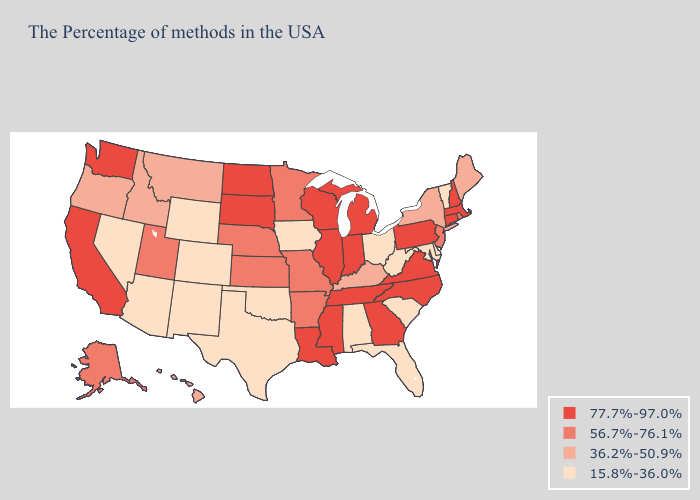Name the states that have a value in the range 36.2%-50.9%?
Keep it brief. Maine, New York, Kentucky, Montana, Idaho, Oregon, Hawaii. What is the lowest value in the Northeast?
Keep it brief. 15.8%-36.0%. Among the states that border Idaho , which have the highest value?
Be succinct. Washington. Does Oregon have a higher value than Louisiana?
Concise answer only. No. What is the value of Pennsylvania?
Keep it brief. 77.7%-97.0%. What is the value of Minnesota?
Concise answer only. 56.7%-76.1%. How many symbols are there in the legend?
Give a very brief answer. 4. What is the lowest value in the South?
Keep it brief. 15.8%-36.0%. Does Oregon have the same value as Kansas?
Concise answer only. No. Name the states that have a value in the range 36.2%-50.9%?
Give a very brief answer. Maine, New York, Kentucky, Montana, Idaho, Oregon, Hawaii. Does California have the highest value in the West?
Concise answer only. Yes. Does the map have missing data?
Quick response, please. No. Name the states that have a value in the range 36.2%-50.9%?
Concise answer only. Maine, New York, Kentucky, Montana, Idaho, Oregon, Hawaii. Among the states that border Missouri , which have the lowest value?
Short answer required. Iowa, Oklahoma. What is the value of Hawaii?
Be succinct. 36.2%-50.9%. 